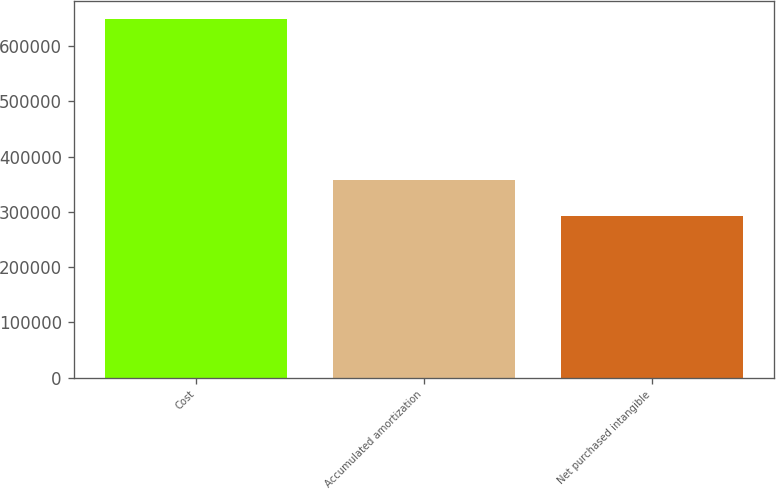Convert chart to OTSL. <chart><loc_0><loc_0><loc_500><loc_500><bar_chart><fcel>Cost<fcel>Accumulated amortization<fcel>Net purchased intangible<nl><fcel>650127<fcel>357243<fcel>292884<nl></chart> 